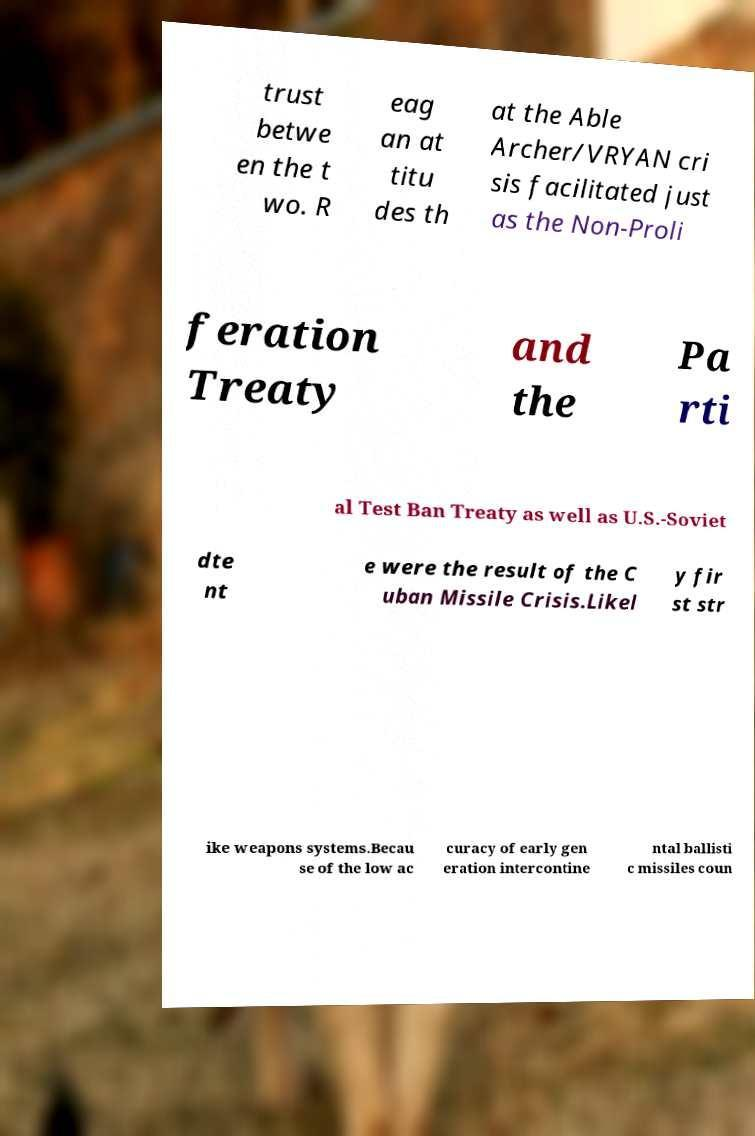Could you extract and type out the text from this image? trust betwe en the t wo. R eag an at titu des th at the Able Archer/VRYAN cri sis facilitated just as the Non-Proli feration Treaty and the Pa rti al Test Ban Treaty as well as U.S.-Soviet dte nt e were the result of the C uban Missile Crisis.Likel y fir st str ike weapons systems.Becau se of the low ac curacy of early gen eration intercontine ntal ballisti c missiles coun 